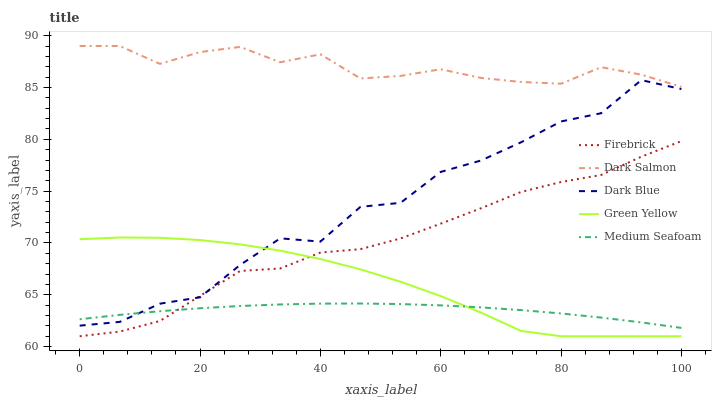Does Medium Seafoam have the minimum area under the curve?
Answer yes or no. Yes. Does Dark Salmon have the maximum area under the curve?
Answer yes or no. Yes. Does Firebrick have the minimum area under the curve?
Answer yes or no. No. Does Firebrick have the maximum area under the curve?
Answer yes or no. No. Is Medium Seafoam the smoothest?
Answer yes or no. Yes. Is Dark Blue the roughest?
Answer yes or no. Yes. Is Firebrick the smoothest?
Answer yes or no. No. Is Firebrick the roughest?
Answer yes or no. No. Does Firebrick have the lowest value?
Answer yes or no. Yes. Does Dark Salmon have the lowest value?
Answer yes or no. No. Does Dark Salmon have the highest value?
Answer yes or no. Yes. Does Firebrick have the highest value?
Answer yes or no. No. Is Green Yellow less than Dark Salmon?
Answer yes or no. Yes. Is Dark Salmon greater than Green Yellow?
Answer yes or no. Yes. Does Firebrick intersect Medium Seafoam?
Answer yes or no. Yes. Is Firebrick less than Medium Seafoam?
Answer yes or no. No. Is Firebrick greater than Medium Seafoam?
Answer yes or no. No. Does Green Yellow intersect Dark Salmon?
Answer yes or no. No. 